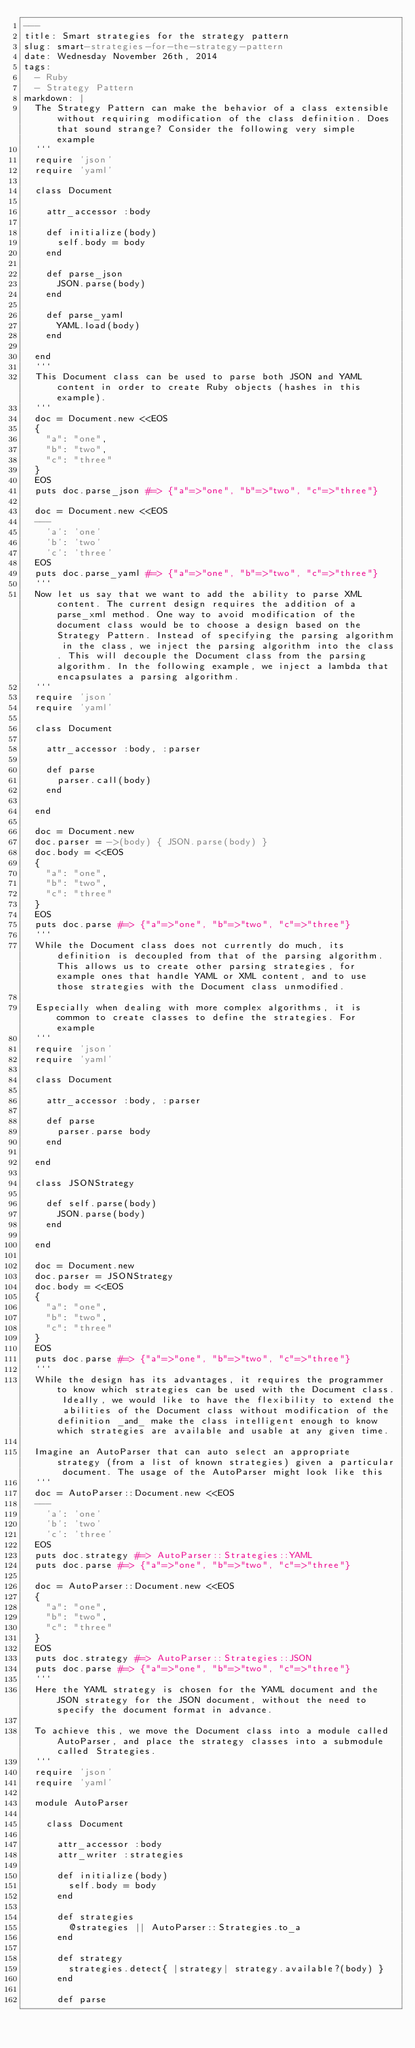Convert code to text. <code><loc_0><loc_0><loc_500><loc_500><_YAML_>---
title: Smart strategies for the strategy pattern
slug: smart-strategies-for-the-strategy-pattern
date: Wednesday November 26th, 2014
tags:
  - Ruby
  - Strategy Pattern
markdown: |
  The Strategy Pattern can make the behavior of a class extensible without requiring modification of the class definition. Does that sound strange? Consider the following very simple example
  ```
  require 'json'
  require 'yaml'

  class Document

    attr_accessor :body

    def initialize(body)
      self.body = body
    end

    def parse_json
      JSON.parse(body)
    end

    def parse_yaml
      YAML.load(body)
    end

  end
  ```
  This Document class can be used to parse both JSON and YAML content in order to create Ruby objects (hashes in this example).
  ```
  doc = Document.new <<EOS
  {
    "a": "one",
    "b": "two",
    "c": "three"
  }
  EOS
  puts doc.parse_json #=> {"a"=>"one", "b"=>"two", "c"=>"three"}

  doc = Document.new <<EOS
  ---
    'a': 'one'
    'b': 'two'
    'c': 'three'
  EOS
  puts doc.parse_yaml #=> {"a"=>"one", "b"=>"two", "c"=>"three"}
  ```
  Now let us say that we want to add the ability to parse XML content. The current design requires the addition of a parse_xml method. One way to avoid modification of the document class would be to choose a design based on the Strategy Pattern. Instead of specifying the parsing algorithm in the class, we inject the parsing algorithm into the class. This will decouple the Document class from the parsing algorithm. In the following example, we inject a lambda that encapsulates a parsing algorithm.
  ```
  require 'json'
  require 'yaml'

  class Document

    attr_accessor :body, :parser

    def parse
      parser.call(body)
    end

  end

  doc = Document.new
  doc.parser = ->(body) { JSON.parse(body) }
  doc.body = <<EOS
  {
    "a": "one",
    "b": "two",
    "c": "three"
  }
  EOS
  puts doc.parse #=> {"a"=>"one", "b"=>"two", "c"=>"three"}
  ```
  While the Document class does not currently do much, its definition is decoupled from that of the parsing algorithm. This allows us to create other parsing strategies, for example ones that handle YAML or XML content, and to use those strategies with the Document class unmodified.

  Especially when dealing with more complex algorithms, it is common to create classes to define the strategies. For example
  ```
  require 'json'
  require 'yaml'

  class Document

    attr_accessor :body, :parser

    def parse
      parser.parse body
    end

  end

  class JSONStrategy

    def self.parse(body)
      JSON.parse(body)
    end

  end

  doc = Document.new
  doc.parser = JSONStrategy
  doc.body = <<EOS
  {
    "a": "one",
    "b": "two",
    "c": "three"
  }
  EOS
  puts doc.parse #=> {"a"=>"one", "b"=>"two", "c"=>"three"}
  ```
  While the design has its advantages, it requires the programmer to know which strategies can be used with the Document class. Ideally, we would like to have the flexibility to extend the abilities of the Document class without modification of the definition _and_ make the class intelligent enough to know which strategies are available and usable at any given time.

  Imagine an AutoParser that can auto select an appropriate strategy (from a list of known strategies) given a particular document. The usage of the AutoParser might look like this
  ```
  doc = AutoParser::Document.new <<EOS
  ---
    'a': 'one'
    'b': 'two'
    'c': 'three'
  EOS
  puts doc.strategy #=> AutoParser::Strategies::YAML
  puts doc.parse #=> {"a"=>"one", "b"=>"two", "c"=>"three"}

  doc = AutoParser::Document.new <<EOS
  {
    "a": "one",
    "b": "two",
    "c": "three"
  }
  EOS
  puts doc.strategy #=> AutoParser::Strategies::JSON
  puts doc.parse #=> {"a"=>"one", "b"=>"two", "c"=>"three"}
  ```
  Here the YAML strategy is chosen for the YAML document and the JSON strategy for the JSON document, without the need to specify the document format in advance.

  To achieve this, we move the Document class into a module called AutoParser, and place the strategy classes into a submodule called Strategies.
  ```
  require 'json'
  require 'yaml'

  module AutoParser

    class Document

      attr_accessor :body
      attr_writer :strategies

      def initialize(body)
        self.body = body
      end

      def strategies
        @strategies || AutoParser::Strategies.to_a
      end

      def strategy
        strategies.detect{ |strategy| strategy.available?(body) }
      end

      def parse</code> 